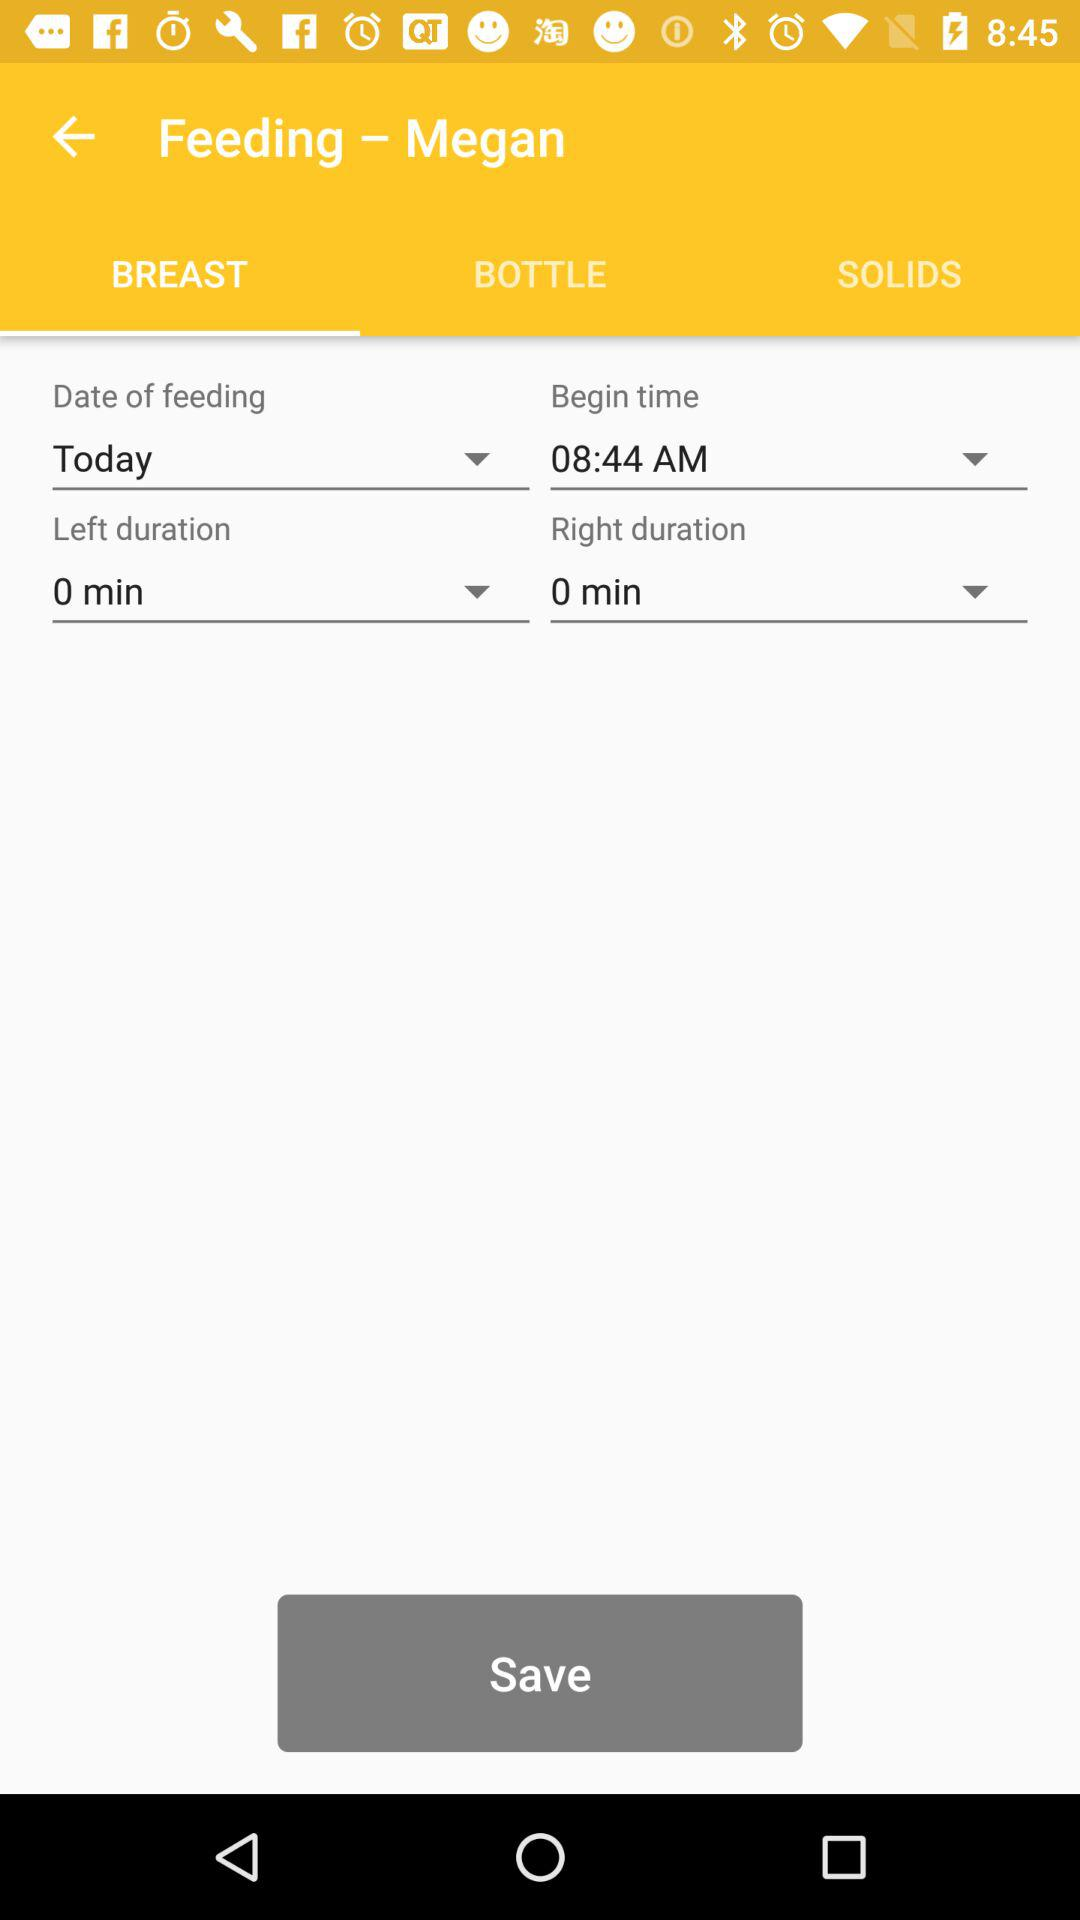How long was the right breast fed for?
Answer the question using a single word or phrase. 0 min 